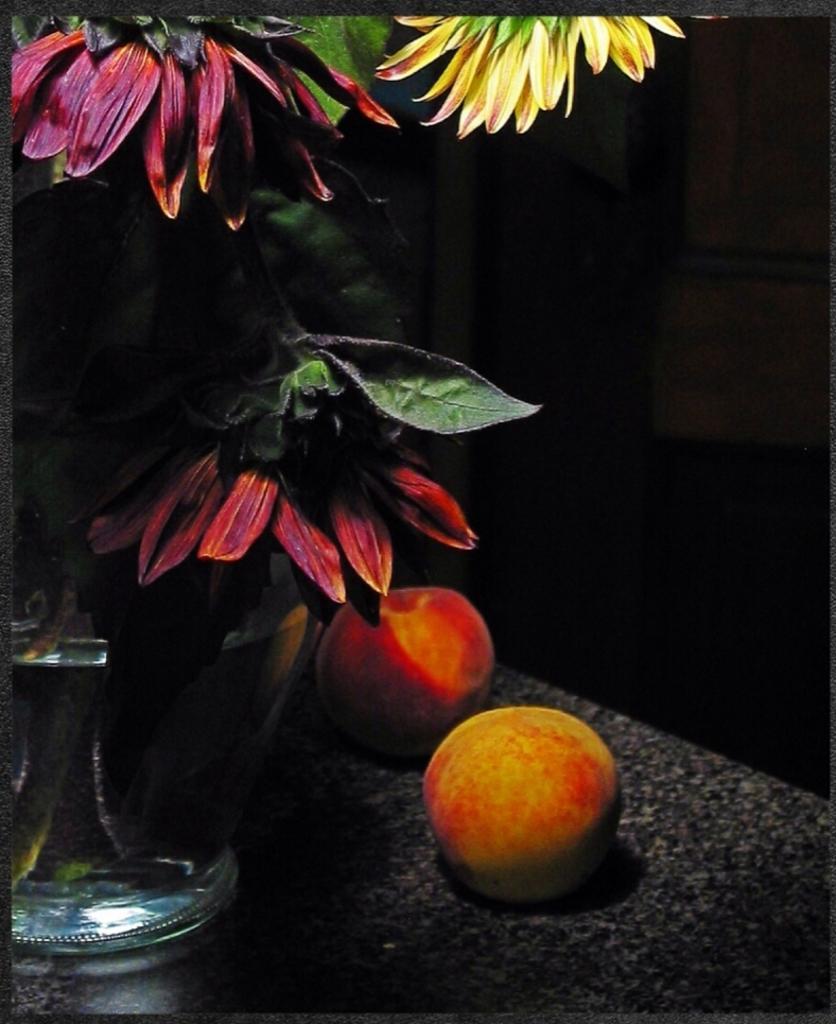Can you describe this image briefly? In this picture we can see a pot and a plant on the left side, there are two fruits in the front, we can see a dark background. 